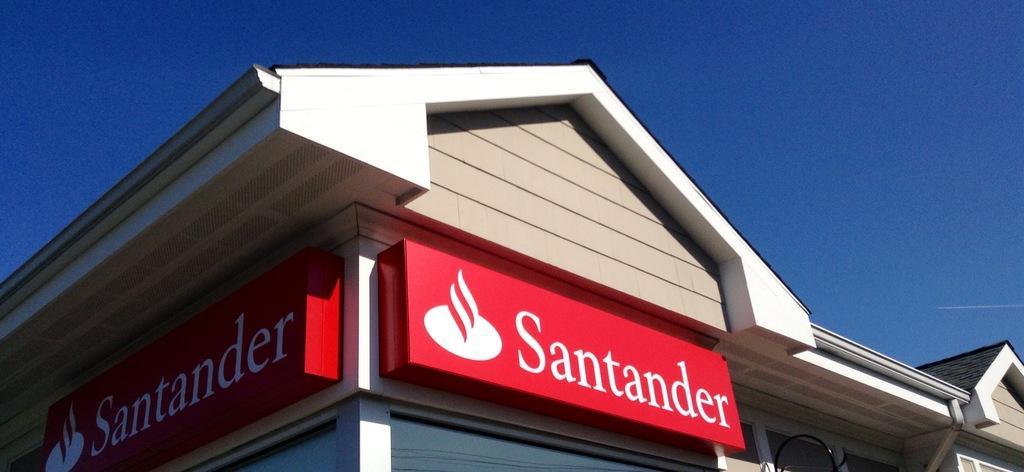Could you give a brief overview of what you see in this image? In this image we can see a house and there is a board which is in red color on which it is written as santander and top of the image there is clear sky. 